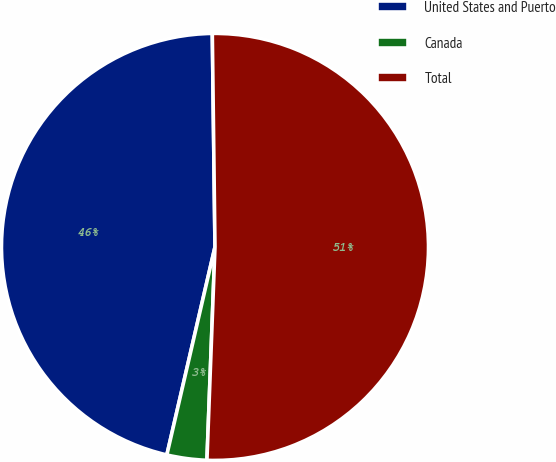<chart> <loc_0><loc_0><loc_500><loc_500><pie_chart><fcel>United States and Puerto<fcel>Canada<fcel>Total<nl><fcel>46.18%<fcel>3.02%<fcel>50.8%<nl></chart> 